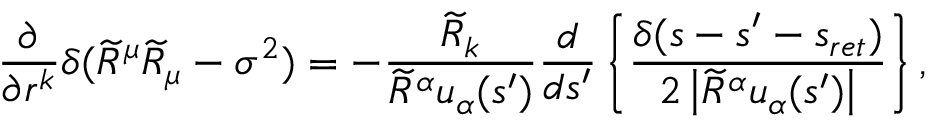Convert formula to latex. <formula><loc_0><loc_0><loc_500><loc_500>\frac { \partial } { \partial r ^ { k } } \delta ( \widetilde { R } ^ { \mu } \widetilde { R } _ { \mu } - \sigma ^ { 2 } ) = - \frac { \widetilde { R } _ { k } } { \widetilde { R } ^ { \alpha } u _ { \alpha } ( s ^ { \prime } ) } \frac { d } { d s ^ { \prime } } \left \{ \frac { \delta ( s - s ^ { \prime } - s _ { r e t } ) } { 2 \left | \widetilde { R } ^ { \alpha } u _ { \alpha } ( s ^ { \prime } ) \right | } \right \} ,</formula> 